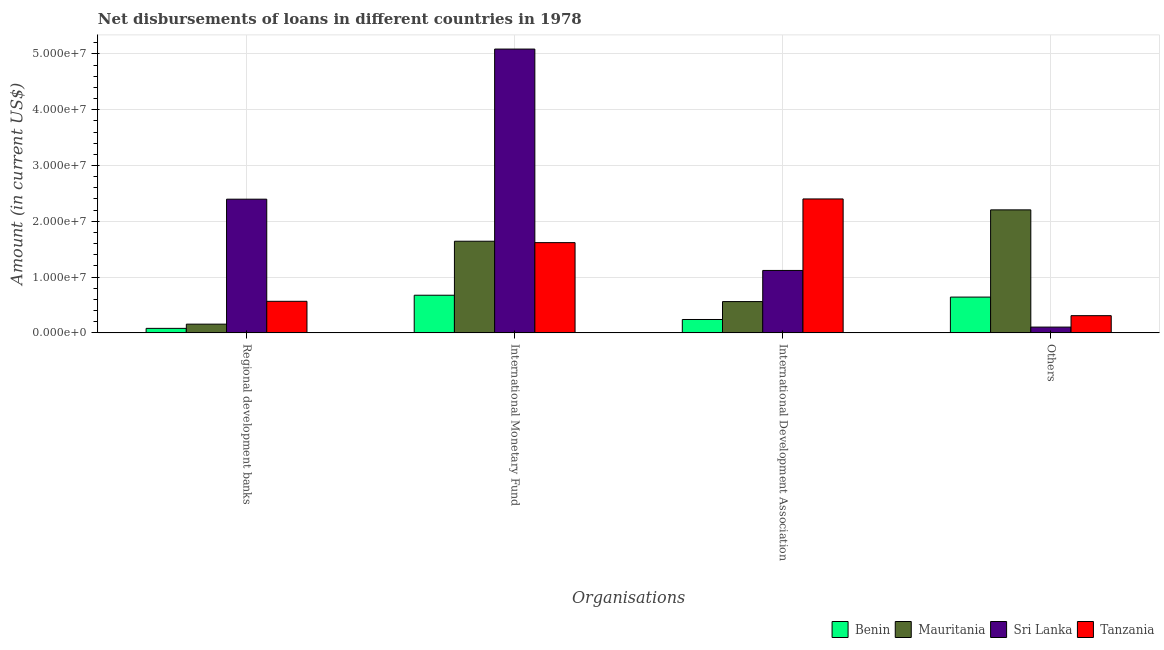How many different coloured bars are there?
Offer a terse response. 4. Are the number of bars per tick equal to the number of legend labels?
Your answer should be compact. Yes. What is the label of the 1st group of bars from the left?
Your answer should be very brief. Regional development banks. What is the amount of loan disimbursed by international monetary fund in Sri Lanka?
Give a very brief answer. 5.09e+07. Across all countries, what is the maximum amount of loan disimbursed by other organisations?
Your response must be concise. 2.20e+07. Across all countries, what is the minimum amount of loan disimbursed by international development association?
Make the answer very short. 2.40e+06. In which country was the amount of loan disimbursed by regional development banks maximum?
Provide a short and direct response. Sri Lanka. In which country was the amount of loan disimbursed by international monetary fund minimum?
Give a very brief answer. Benin. What is the total amount of loan disimbursed by international monetary fund in the graph?
Give a very brief answer. 9.02e+07. What is the difference between the amount of loan disimbursed by international monetary fund in Benin and that in Tanzania?
Keep it short and to the point. -9.42e+06. What is the difference between the amount of loan disimbursed by international monetary fund in Mauritania and the amount of loan disimbursed by other organisations in Sri Lanka?
Give a very brief answer. 1.54e+07. What is the average amount of loan disimbursed by other organisations per country?
Your response must be concise. 8.14e+06. What is the difference between the amount of loan disimbursed by other organisations and amount of loan disimbursed by regional development banks in Benin?
Keep it short and to the point. 5.61e+06. What is the ratio of the amount of loan disimbursed by international development association in Benin to that in Sri Lanka?
Keep it short and to the point. 0.21. What is the difference between the highest and the second highest amount of loan disimbursed by international development association?
Provide a succinct answer. 1.28e+07. What is the difference between the highest and the lowest amount of loan disimbursed by other organisations?
Make the answer very short. 2.10e+07. In how many countries, is the amount of loan disimbursed by regional development banks greater than the average amount of loan disimbursed by regional development banks taken over all countries?
Offer a very short reply. 1. Is the sum of the amount of loan disimbursed by other organisations in Tanzania and Sri Lanka greater than the maximum amount of loan disimbursed by international development association across all countries?
Your response must be concise. No. Is it the case that in every country, the sum of the amount of loan disimbursed by other organisations and amount of loan disimbursed by regional development banks is greater than the sum of amount of loan disimbursed by international monetary fund and amount of loan disimbursed by international development association?
Your response must be concise. No. What does the 2nd bar from the left in International Development Association represents?
Offer a terse response. Mauritania. What does the 3rd bar from the right in International Monetary Fund represents?
Provide a succinct answer. Mauritania. How many bars are there?
Offer a very short reply. 16. Are all the bars in the graph horizontal?
Your response must be concise. No. Are the values on the major ticks of Y-axis written in scientific E-notation?
Provide a short and direct response. Yes. Does the graph contain any zero values?
Keep it short and to the point. No. How are the legend labels stacked?
Provide a succinct answer. Horizontal. What is the title of the graph?
Your answer should be very brief. Net disbursements of loans in different countries in 1978. Does "Colombia" appear as one of the legend labels in the graph?
Make the answer very short. No. What is the label or title of the X-axis?
Make the answer very short. Organisations. What is the Amount (in current US$) of Benin in Regional development banks?
Your answer should be very brief. 8.06e+05. What is the Amount (in current US$) of Mauritania in Regional development banks?
Ensure brevity in your answer.  1.56e+06. What is the Amount (in current US$) of Sri Lanka in Regional development banks?
Provide a succinct answer. 2.40e+07. What is the Amount (in current US$) in Tanzania in Regional development banks?
Make the answer very short. 5.66e+06. What is the Amount (in current US$) in Benin in International Monetary Fund?
Your answer should be very brief. 6.75e+06. What is the Amount (in current US$) of Mauritania in International Monetary Fund?
Offer a terse response. 1.64e+07. What is the Amount (in current US$) in Sri Lanka in International Monetary Fund?
Keep it short and to the point. 5.09e+07. What is the Amount (in current US$) of Tanzania in International Monetary Fund?
Offer a very short reply. 1.62e+07. What is the Amount (in current US$) of Benin in International Development Association?
Your answer should be very brief. 2.40e+06. What is the Amount (in current US$) in Mauritania in International Development Association?
Ensure brevity in your answer.  5.61e+06. What is the Amount (in current US$) in Sri Lanka in International Development Association?
Make the answer very short. 1.12e+07. What is the Amount (in current US$) of Tanzania in International Development Association?
Your answer should be compact. 2.40e+07. What is the Amount (in current US$) in Benin in Others?
Offer a very short reply. 6.41e+06. What is the Amount (in current US$) of Mauritania in Others?
Provide a succinct answer. 2.20e+07. What is the Amount (in current US$) of Sri Lanka in Others?
Give a very brief answer. 1.04e+06. What is the Amount (in current US$) of Tanzania in Others?
Your answer should be compact. 3.08e+06. Across all Organisations, what is the maximum Amount (in current US$) in Benin?
Your answer should be very brief. 6.75e+06. Across all Organisations, what is the maximum Amount (in current US$) of Mauritania?
Offer a very short reply. 2.20e+07. Across all Organisations, what is the maximum Amount (in current US$) in Sri Lanka?
Keep it short and to the point. 5.09e+07. Across all Organisations, what is the maximum Amount (in current US$) of Tanzania?
Provide a short and direct response. 2.40e+07. Across all Organisations, what is the minimum Amount (in current US$) of Benin?
Provide a short and direct response. 8.06e+05. Across all Organisations, what is the minimum Amount (in current US$) in Mauritania?
Give a very brief answer. 1.56e+06. Across all Organisations, what is the minimum Amount (in current US$) of Sri Lanka?
Your answer should be compact. 1.04e+06. Across all Organisations, what is the minimum Amount (in current US$) of Tanzania?
Keep it short and to the point. 3.08e+06. What is the total Amount (in current US$) in Benin in the graph?
Your answer should be compact. 1.64e+07. What is the total Amount (in current US$) in Mauritania in the graph?
Keep it short and to the point. 4.56e+07. What is the total Amount (in current US$) in Sri Lanka in the graph?
Provide a succinct answer. 8.71e+07. What is the total Amount (in current US$) in Tanzania in the graph?
Give a very brief answer. 4.89e+07. What is the difference between the Amount (in current US$) in Benin in Regional development banks and that in International Monetary Fund?
Make the answer very short. -5.94e+06. What is the difference between the Amount (in current US$) in Mauritania in Regional development banks and that in International Monetary Fund?
Offer a very short reply. -1.49e+07. What is the difference between the Amount (in current US$) of Sri Lanka in Regional development banks and that in International Monetary Fund?
Your response must be concise. -2.69e+07. What is the difference between the Amount (in current US$) of Tanzania in Regional development banks and that in International Monetary Fund?
Give a very brief answer. -1.05e+07. What is the difference between the Amount (in current US$) in Benin in Regional development banks and that in International Development Association?
Ensure brevity in your answer.  -1.59e+06. What is the difference between the Amount (in current US$) of Mauritania in Regional development banks and that in International Development Association?
Make the answer very short. -4.04e+06. What is the difference between the Amount (in current US$) of Sri Lanka in Regional development banks and that in International Development Association?
Your answer should be very brief. 1.28e+07. What is the difference between the Amount (in current US$) of Tanzania in Regional development banks and that in International Development Association?
Your answer should be very brief. -1.84e+07. What is the difference between the Amount (in current US$) in Benin in Regional development banks and that in Others?
Provide a succinct answer. -5.61e+06. What is the difference between the Amount (in current US$) in Mauritania in Regional development banks and that in Others?
Your answer should be compact. -2.05e+07. What is the difference between the Amount (in current US$) in Sri Lanka in Regional development banks and that in Others?
Give a very brief answer. 2.29e+07. What is the difference between the Amount (in current US$) in Tanzania in Regional development banks and that in Others?
Your answer should be very brief. 2.57e+06. What is the difference between the Amount (in current US$) in Benin in International Monetary Fund and that in International Development Association?
Ensure brevity in your answer.  4.35e+06. What is the difference between the Amount (in current US$) of Mauritania in International Monetary Fund and that in International Development Association?
Your answer should be compact. 1.08e+07. What is the difference between the Amount (in current US$) in Sri Lanka in International Monetary Fund and that in International Development Association?
Your answer should be very brief. 3.97e+07. What is the difference between the Amount (in current US$) of Tanzania in International Monetary Fund and that in International Development Association?
Provide a succinct answer. -7.83e+06. What is the difference between the Amount (in current US$) in Benin in International Monetary Fund and that in Others?
Offer a terse response. 3.34e+05. What is the difference between the Amount (in current US$) of Mauritania in International Monetary Fund and that in Others?
Give a very brief answer. -5.62e+06. What is the difference between the Amount (in current US$) in Sri Lanka in International Monetary Fund and that in Others?
Ensure brevity in your answer.  4.98e+07. What is the difference between the Amount (in current US$) in Tanzania in International Monetary Fund and that in Others?
Offer a terse response. 1.31e+07. What is the difference between the Amount (in current US$) of Benin in International Development Association and that in Others?
Make the answer very short. -4.02e+06. What is the difference between the Amount (in current US$) in Mauritania in International Development Association and that in Others?
Keep it short and to the point. -1.64e+07. What is the difference between the Amount (in current US$) in Sri Lanka in International Development Association and that in Others?
Your answer should be compact. 1.02e+07. What is the difference between the Amount (in current US$) in Tanzania in International Development Association and that in Others?
Make the answer very short. 2.09e+07. What is the difference between the Amount (in current US$) of Benin in Regional development banks and the Amount (in current US$) of Mauritania in International Monetary Fund?
Keep it short and to the point. -1.56e+07. What is the difference between the Amount (in current US$) in Benin in Regional development banks and the Amount (in current US$) in Sri Lanka in International Monetary Fund?
Your answer should be very brief. -5.01e+07. What is the difference between the Amount (in current US$) in Benin in Regional development banks and the Amount (in current US$) in Tanzania in International Monetary Fund?
Your answer should be very brief. -1.54e+07. What is the difference between the Amount (in current US$) in Mauritania in Regional development banks and the Amount (in current US$) in Sri Lanka in International Monetary Fund?
Your answer should be very brief. -4.93e+07. What is the difference between the Amount (in current US$) of Mauritania in Regional development banks and the Amount (in current US$) of Tanzania in International Monetary Fund?
Ensure brevity in your answer.  -1.46e+07. What is the difference between the Amount (in current US$) of Sri Lanka in Regional development banks and the Amount (in current US$) of Tanzania in International Monetary Fund?
Your response must be concise. 7.79e+06. What is the difference between the Amount (in current US$) of Benin in Regional development banks and the Amount (in current US$) of Mauritania in International Development Association?
Provide a succinct answer. -4.80e+06. What is the difference between the Amount (in current US$) in Benin in Regional development banks and the Amount (in current US$) in Sri Lanka in International Development Association?
Offer a very short reply. -1.04e+07. What is the difference between the Amount (in current US$) of Benin in Regional development banks and the Amount (in current US$) of Tanzania in International Development Association?
Keep it short and to the point. -2.32e+07. What is the difference between the Amount (in current US$) of Mauritania in Regional development banks and the Amount (in current US$) of Sri Lanka in International Development Association?
Give a very brief answer. -9.63e+06. What is the difference between the Amount (in current US$) in Mauritania in Regional development banks and the Amount (in current US$) in Tanzania in International Development Association?
Ensure brevity in your answer.  -2.24e+07. What is the difference between the Amount (in current US$) in Sri Lanka in Regional development banks and the Amount (in current US$) in Tanzania in International Development Association?
Give a very brief answer. -4.30e+04. What is the difference between the Amount (in current US$) of Benin in Regional development banks and the Amount (in current US$) of Mauritania in Others?
Keep it short and to the point. -2.12e+07. What is the difference between the Amount (in current US$) of Benin in Regional development banks and the Amount (in current US$) of Sri Lanka in Others?
Your response must be concise. -2.29e+05. What is the difference between the Amount (in current US$) in Benin in Regional development banks and the Amount (in current US$) in Tanzania in Others?
Provide a short and direct response. -2.28e+06. What is the difference between the Amount (in current US$) in Mauritania in Regional development banks and the Amount (in current US$) in Sri Lanka in Others?
Keep it short and to the point. 5.29e+05. What is the difference between the Amount (in current US$) in Mauritania in Regional development banks and the Amount (in current US$) in Tanzania in Others?
Your answer should be very brief. -1.52e+06. What is the difference between the Amount (in current US$) in Sri Lanka in Regional development banks and the Amount (in current US$) in Tanzania in Others?
Your answer should be compact. 2.09e+07. What is the difference between the Amount (in current US$) of Benin in International Monetary Fund and the Amount (in current US$) of Mauritania in International Development Association?
Offer a terse response. 1.14e+06. What is the difference between the Amount (in current US$) of Benin in International Monetary Fund and the Amount (in current US$) of Sri Lanka in International Development Association?
Offer a terse response. -4.44e+06. What is the difference between the Amount (in current US$) of Benin in International Monetary Fund and the Amount (in current US$) of Tanzania in International Development Association?
Your answer should be very brief. -1.73e+07. What is the difference between the Amount (in current US$) in Mauritania in International Monetary Fund and the Amount (in current US$) in Sri Lanka in International Development Association?
Your answer should be very brief. 5.24e+06. What is the difference between the Amount (in current US$) in Mauritania in International Monetary Fund and the Amount (in current US$) in Tanzania in International Development Association?
Your response must be concise. -7.58e+06. What is the difference between the Amount (in current US$) of Sri Lanka in International Monetary Fund and the Amount (in current US$) of Tanzania in International Development Association?
Your response must be concise. 2.69e+07. What is the difference between the Amount (in current US$) in Benin in International Monetary Fund and the Amount (in current US$) in Mauritania in Others?
Provide a short and direct response. -1.53e+07. What is the difference between the Amount (in current US$) in Benin in International Monetary Fund and the Amount (in current US$) in Sri Lanka in Others?
Provide a succinct answer. 5.71e+06. What is the difference between the Amount (in current US$) of Benin in International Monetary Fund and the Amount (in current US$) of Tanzania in Others?
Keep it short and to the point. 3.66e+06. What is the difference between the Amount (in current US$) in Mauritania in International Monetary Fund and the Amount (in current US$) in Sri Lanka in Others?
Your answer should be very brief. 1.54e+07. What is the difference between the Amount (in current US$) of Mauritania in International Monetary Fund and the Amount (in current US$) of Tanzania in Others?
Offer a very short reply. 1.33e+07. What is the difference between the Amount (in current US$) in Sri Lanka in International Monetary Fund and the Amount (in current US$) in Tanzania in Others?
Your answer should be compact. 4.78e+07. What is the difference between the Amount (in current US$) in Benin in International Development Association and the Amount (in current US$) in Mauritania in Others?
Make the answer very short. -1.96e+07. What is the difference between the Amount (in current US$) of Benin in International Development Association and the Amount (in current US$) of Sri Lanka in Others?
Keep it short and to the point. 1.36e+06. What is the difference between the Amount (in current US$) of Benin in International Development Association and the Amount (in current US$) of Tanzania in Others?
Your answer should be very brief. -6.87e+05. What is the difference between the Amount (in current US$) in Mauritania in International Development Association and the Amount (in current US$) in Sri Lanka in Others?
Your answer should be compact. 4.57e+06. What is the difference between the Amount (in current US$) of Mauritania in International Development Association and the Amount (in current US$) of Tanzania in Others?
Provide a short and direct response. 2.52e+06. What is the difference between the Amount (in current US$) in Sri Lanka in International Development Association and the Amount (in current US$) in Tanzania in Others?
Give a very brief answer. 8.11e+06. What is the average Amount (in current US$) in Benin per Organisations?
Provide a succinct answer. 4.09e+06. What is the average Amount (in current US$) of Mauritania per Organisations?
Your answer should be very brief. 1.14e+07. What is the average Amount (in current US$) in Sri Lanka per Organisations?
Provide a short and direct response. 2.18e+07. What is the average Amount (in current US$) of Tanzania per Organisations?
Offer a very short reply. 1.22e+07. What is the difference between the Amount (in current US$) in Benin and Amount (in current US$) in Mauritania in Regional development banks?
Your answer should be compact. -7.58e+05. What is the difference between the Amount (in current US$) of Benin and Amount (in current US$) of Sri Lanka in Regional development banks?
Give a very brief answer. -2.32e+07. What is the difference between the Amount (in current US$) in Benin and Amount (in current US$) in Tanzania in Regional development banks?
Your answer should be very brief. -4.85e+06. What is the difference between the Amount (in current US$) in Mauritania and Amount (in current US$) in Sri Lanka in Regional development banks?
Keep it short and to the point. -2.24e+07. What is the difference between the Amount (in current US$) in Mauritania and Amount (in current US$) in Tanzania in Regional development banks?
Make the answer very short. -4.09e+06. What is the difference between the Amount (in current US$) in Sri Lanka and Amount (in current US$) in Tanzania in Regional development banks?
Give a very brief answer. 1.83e+07. What is the difference between the Amount (in current US$) in Benin and Amount (in current US$) in Mauritania in International Monetary Fund?
Offer a very short reply. -9.68e+06. What is the difference between the Amount (in current US$) of Benin and Amount (in current US$) of Sri Lanka in International Monetary Fund?
Your response must be concise. -4.41e+07. What is the difference between the Amount (in current US$) in Benin and Amount (in current US$) in Tanzania in International Monetary Fund?
Provide a succinct answer. -9.42e+06. What is the difference between the Amount (in current US$) of Mauritania and Amount (in current US$) of Sri Lanka in International Monetary Fund?
Offer a very short reply. -3.44e+07. What is the difference between the Amount (in current US$) in Mauritania and Amount (in current US$) in Tanzania in International Monetary Fund?
Keep it short and to the point. 2.52e+05. What is the difference between the Amount (in current US$) of Sri Lanka and Amount (in current US$) of Tanzania in International Monetary Fund?
Keep it short and to the point. 3.47e+07. What is the difference between the Amount (in current US$) of Benin and Amount (in current US$) of Mauritania in International Development Association?
Offer a terse response. -3.21e+06. What is the difference between the Amount (in current US$) in Benin and Amount (in current US$) in Sri Lanka in International Development Association?
Keep it short and to the point. -8.79e+06. What is the difference between the Amount (in current US$) of Benin and Amount (in current US$) of Tanzania in International Development Association?
Your response must be concise. -2.16e+07. What is the difference between the Amount (in current US$) in Mauritania and Amount (in current US$) in Sri Lanka in International Development Association?
Offer a terse response. -5.58e+06. What is the difference between the Amount (in current US$) of Mauritania and Amount (in current US$) of Tanzania in International Development Association?
Offer a terse response. -1.84e+07. What is the difference between the Amount (in current US$) in Sri Lanka and Amount (in current US$) in Tanzania in International Development Association?
Give a very brief answer. -1.28e+07. What is the difference between the Amount (in current US$) of Benin and Amount (in current US$) of Mauritania in Others?
Your response must be concise. -1.56e+07. What is the difference between the Amount (in current US$) of Benin and Amount (in current US$) of Sri Lanka in Others?
Ensure brevity in your answer.  5.38e+06. What is the difference between the Amount (in current US$) in Benin and Amount (in current US$) in Tanzania in Others?
Your answer should be very brief. 3.33e+06. What is the difference between the Amount (in current US$) of Mauritania and Amount (in current US$) of Sri Lanka in Others?
Give a very brief answer. 2.10e+07. What is the difference between the Amount (in current US$) in Mauritania and Amount (in current US$) in Tanzania in Others?
Keep it short and to the point. 1.90e+07. What is the difference between the Amount (in current US$) of Sri Lanka and Amount (in current US$) of Tanzania in Others?
Keep it short and to the point. -2.05e+06. What is the ratio of the Amount (in current US$) of Benin in Regional development banks to that in International Monetary Fund?
Ensure brevity in your answer.  0.12. What is the ratio of the Amount (in current US$) in Mauritania in Regional development banks to that in International Monetary Fund?
Your response must be concise. 0.1. What is the ratio of the Amount (in current US$) in Sri Lanka in Regional development banks to that in International Monetary Fund?
Provide a short and direct response. 0.47. What is the ratio of the Amount (in current US$) in Tanzania in Regional development banks to that in International Monetary Fund?
Provide a succinct answer. 0.35. What is the ratio of the Amount (in current US$) in Benin in Regional development banks to that in International Development Association?
Your answer should be very brief. 0.34. What is the ratio of the Amount (in current US$) of Mauritania in Regional development banks to that in International Development Association?
Your answer should be very brief. 0.28. What is the ratio of the Amount (in current US$) of Sri Lanka in Regional development banks to that in International Development Association?
Offer a terse response. 2.14. What is the ratio of the Amount (in current US$) in Tanzania in Regional development banks to that in International Development Association?
Ensure brevity in your answer.  0.24. What is the ratio of the Amount (in current US$) in Benin in Regional development banks to that in Others?
Provide a short and direct response. 0.13. What is the ratio of the Amount (in current US$) in Mauritania in Regional development banks to that in Others?
Ensure brevity in your answer.  0.07. What is the ratio of the Amount (in current US$) in Sri Lanka in Regional development banks to that in Others?
Make the answer very short. 23.15. What is the ratio of the Amount (in current US$) in Tanzania in Regional development banks to that in Others?
Give a very brief answer. 1.83. What is the ratio of the Amount (in current US$) in Benin in International Monetary Fund to that in International Development Association?
Provide a short and direct response. 2.82. What is the ratio of the Amount (in current US$) in Mauritania in International Monetary Fund to that in International Development Association?
Your response must be concise. 2.93. What is the ratio of the Amount (in current US$) of Sri Lanka in International Monetary Fund to that in International Development Association?
Give a very brief answer. 4.55. What is the ratio of the Amount (in current US$) in Tanzania in International Monetary Fund to that in International Development Association?
Ensure brevity in your answer.  0.67. What is the ratio of the Amount (in current US$) in Benin in International Monetary Fund to that in Others?
Keep it short and to the point. 1.05. What is the ratio of the Amount (in current US$) in Mauritania in International Monetary Fund to that in Others?
Make the answer very short. 0.74. What is the ratio of the Amount (in current US$) of Sri Lanka in International Monetary Fund to that in Others?
Offer a very short reply. 49.15. What is the ratio of the Amount (in current US$) in Tanzania in International Monetary Fund to that in Others?
Offer a terse response. 5.24. What is the ratio of the Amount (in current US$) of Benin in International Development Association to that in Others?
Your answer should be compact. 0.37. What is the ratio of the Amount (in current US$) of Mauritania in International Development Association to that in Others?
Offer a very short reply. 0.25. What is the ratio of the Amount (in current US$) of Sri Lanka in International Development Association to that in Others?
Make the answer very short. 10.81. What is the ratio of the Amount (in current US$) in Tanzania in International Development Association to that in Others?
Provide a short and direct response. 7.78. What is the difference between the highest and the second highest Amount (in current US$) of Benin?
Keep it short and to the point. 3.34e+05. What is the difference between the highest and the second highest Amount (in current US$) of Mauritania?
Ensure brevity in your answer.  5.62e+06. What is the difference between the highest and the second highest Amount (in current US$) in Sri Lanka?
Your answer should be compact. 2.69e+07. What is the difference between the highest and the second highest Amount (in current US$) of Tanzania?
Your response must be concise. 7.83e+06. What is the difference between the highest and the lowest Amount (in current US$) in Benin?
Keep it short and to the point. 5.94e+06. What is the difference between the highest and the lowest Amount (in current US$) of Mauritania?
Your answer should be very brief. 2.05e+07. What is the difference between the highest and the lowest Amount (in current US$) in Sri Lanka?
Your answer should be compact. 4.98e+07. What is the difference between the highest and the lowest Amount (in current US$) in Tanzania?
Your answer should be very brief. 2.09e+07. 